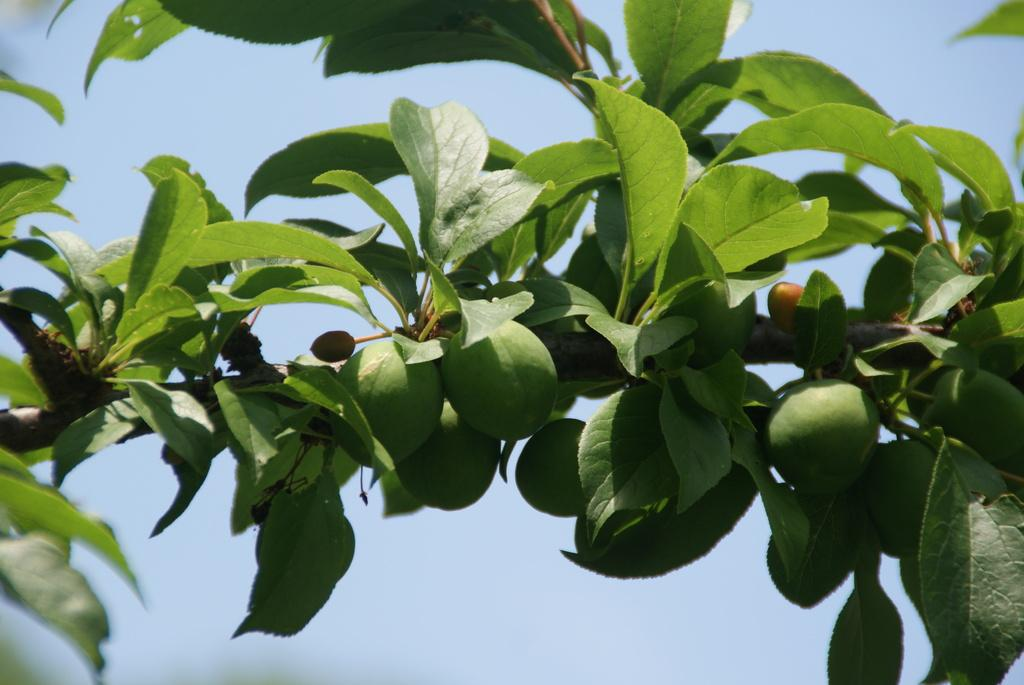What is the main subject of the image? The main subject of the image is a branch of a tree. What can be observed about the branch? The branch has leaves and fruits. What can be seen in the background of the image? The sky is visible in the background of the image. What type of soap is being used to fight off the fruits on the branch in the image? There is no soap or fighting depicted in the image; it simply shows a branch with leaves and fruits. 